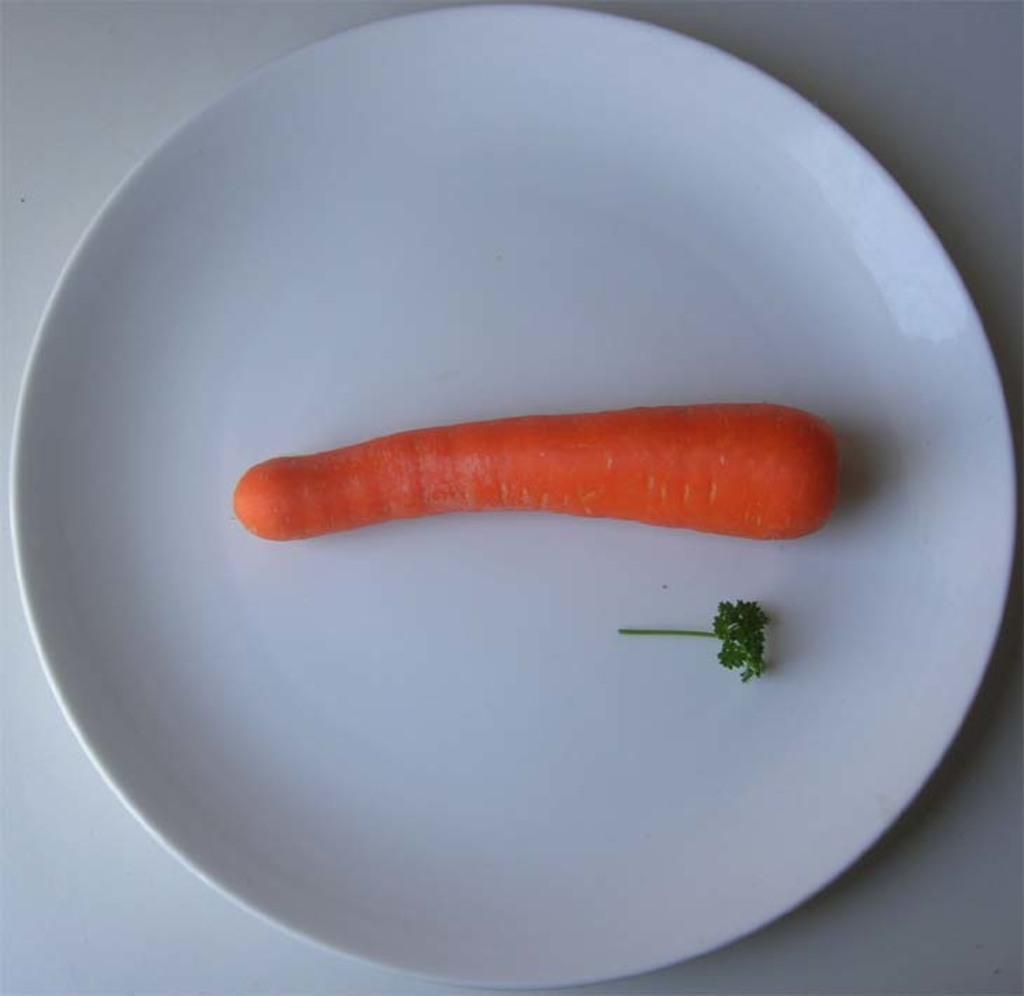In one or two sentences, can you explain what this image depicts? In this image on a white plate there is a carrot, some leafy vegetable is there. The background is white. 